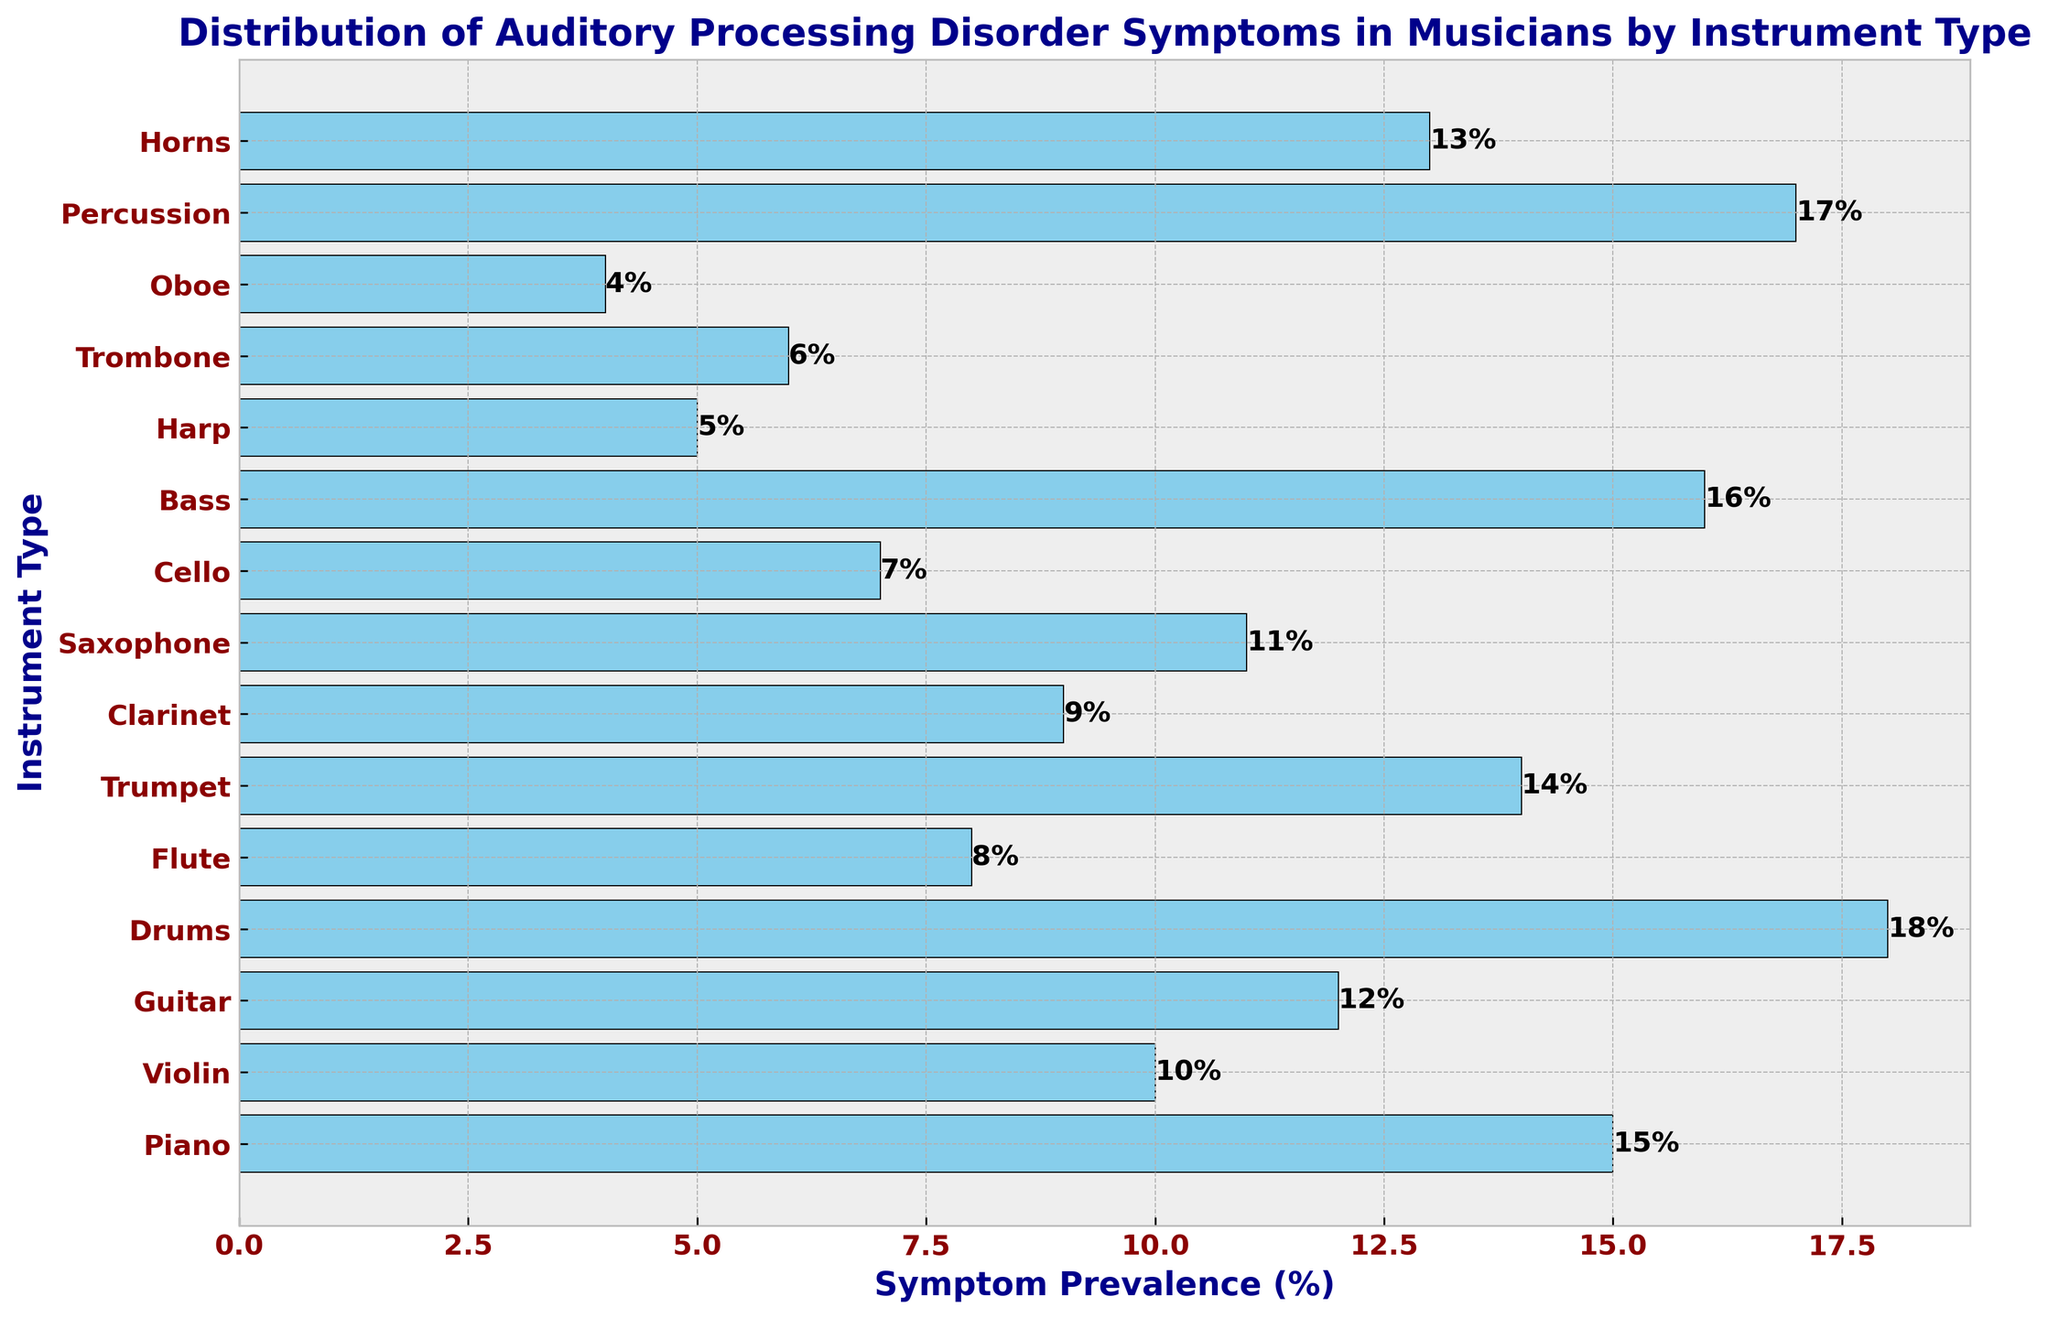Which instrument type has the highest symptom prevalence of auditory processing disorder? The instrument type with the highest bar length on the chart represents the highest symptom prevalence percentage and is colored in skyblue with a black edge. In this case, Drums have the highest prevalence at 18%.
Answer: Drums Which instrument type has the lowest symptom prevalence of auditory processing disorder? The instrument type with the shortest bar length on the chart represents the lowest symptom prevalence percentage and is colored in skyblue with a black edge. In this case, Oboe has the lowest prevalence at 4%.
Answer: Oboe How much greater is the symptom prevalence in Bass players compared to Piano players? Find the difference in the prevalence percentages between Bass (16%) and Piano (15%). Subtract the percentage for Piano from the percentage for Bass.
Answer: 1% Which instrument types have a symptom prevalence higher than 15%? Identify all the bars in the chart with lengths greater than 15%. Drums (18%), Percussion (17%), and Bass (16%) are the instrument types with symptom prevalence higher than 15%.
Answer: Drums, Percussion, Bass How many instrument types have a symptom prevalence below 10%? Count the number of bars in the chart with lengths less than 10%. These instrument types are Flute, Clarinet, Cello, Harp, Trombone, and Oboe. There are six such instruments.
Answer: 6 What is the average symptom prevalence percentage for the instruments Piano, Violin, and Guitar? Calculate the mean of the percentages for Piano (15%), Violin (10%), and Guitar (12%). Sum the percentages: 15 + 10 + 12 = 37, then divide by the number of instruments (3). The average is 37/3 = 12.33%.
Answer: 12.33% Which two instrument types have symptom prevalences that add up to 21%? Look for pairs of bars whose lengths sum to 21%. Violin (10%) and Saxophone (11%) together have a total symptom prevalence of 21%.
Answer: Violin and Saxophone Which instrument has a 1% higher prevalence than Saxophone? Saxophone has a prevalence of 11%. The instrument with a prevalence of 12% is Guitar. Subtracting 11% from 12% yields the difference of 1%.
Answer: Guitar Rank the top three instruments based on their symptom prevalence percentages. Order the instruments by the length of their bars from highest to lowest. The top three instruments are Drums (18%), Percussion (17%), and Bass (16%).
Answer: Drums, Percussion, Bass 